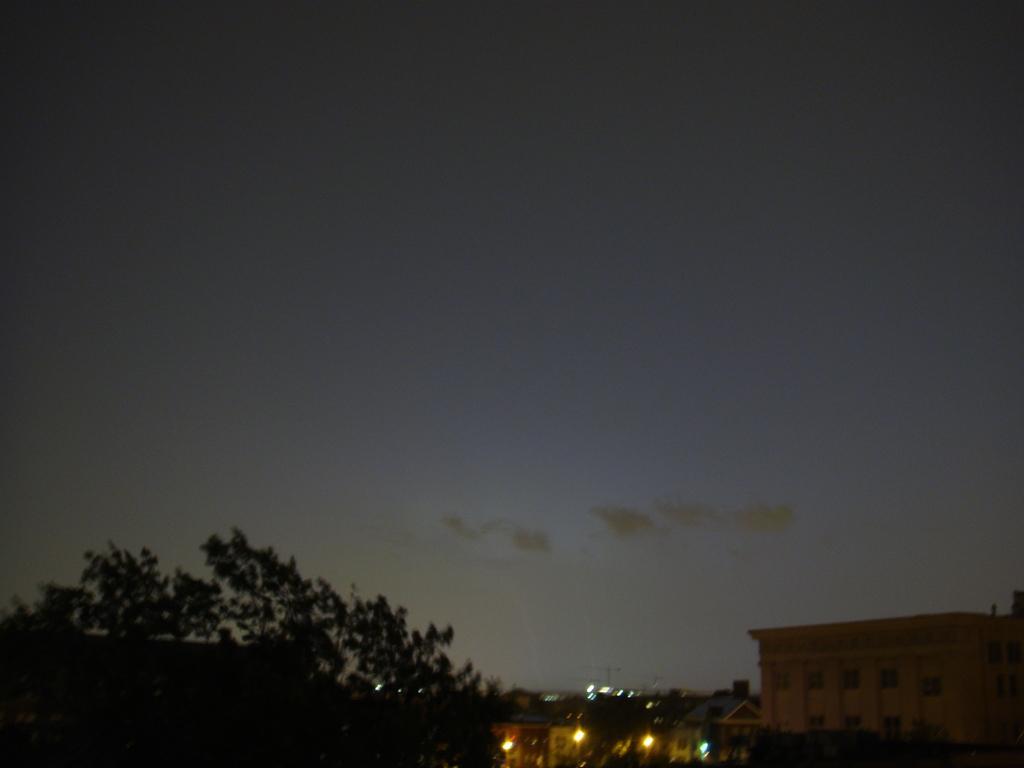How would you summarize this image in a sentence or two? I can see the clouds in the sky. This looks like a tree. At the bottom of the image, I think these are the buildings and the lights. 